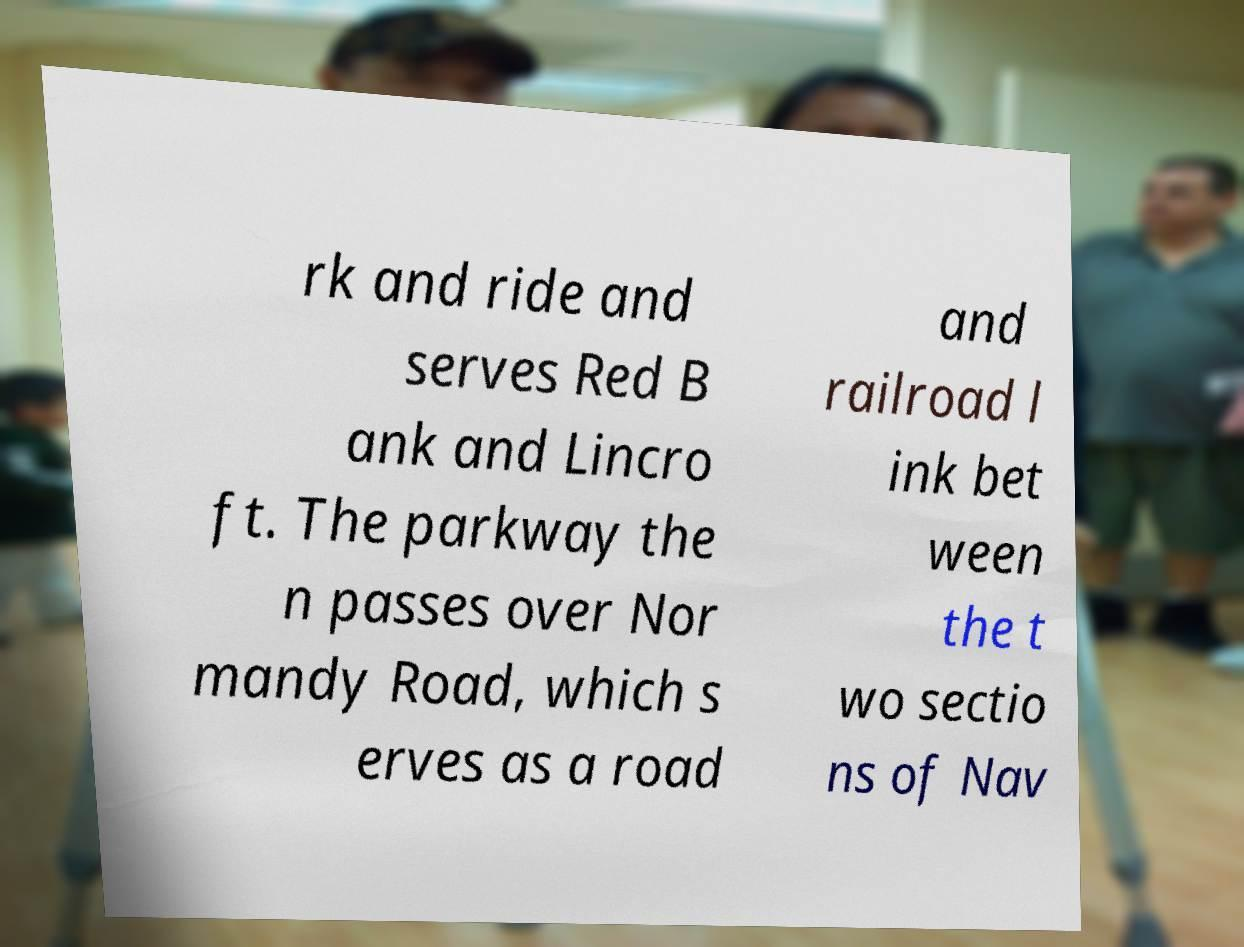Could you extract and type out the text from this image? rk and ride and serves Red B ank and Lincro ft. The parkway the n passes over Nor mandy Road, which s erves as a road and railroad l ink bet ween the t wo sectio ns of Nav 